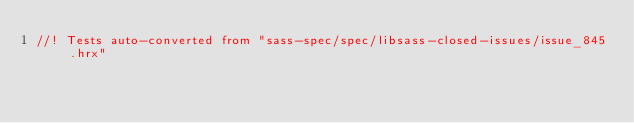<code> <loc_0><loc_0><loc_500><loc_500><_Rust_>//! Tests auto-converted from "sass-spec/spec/libsass-closed-issues/issue_845.hrx"
</code> 